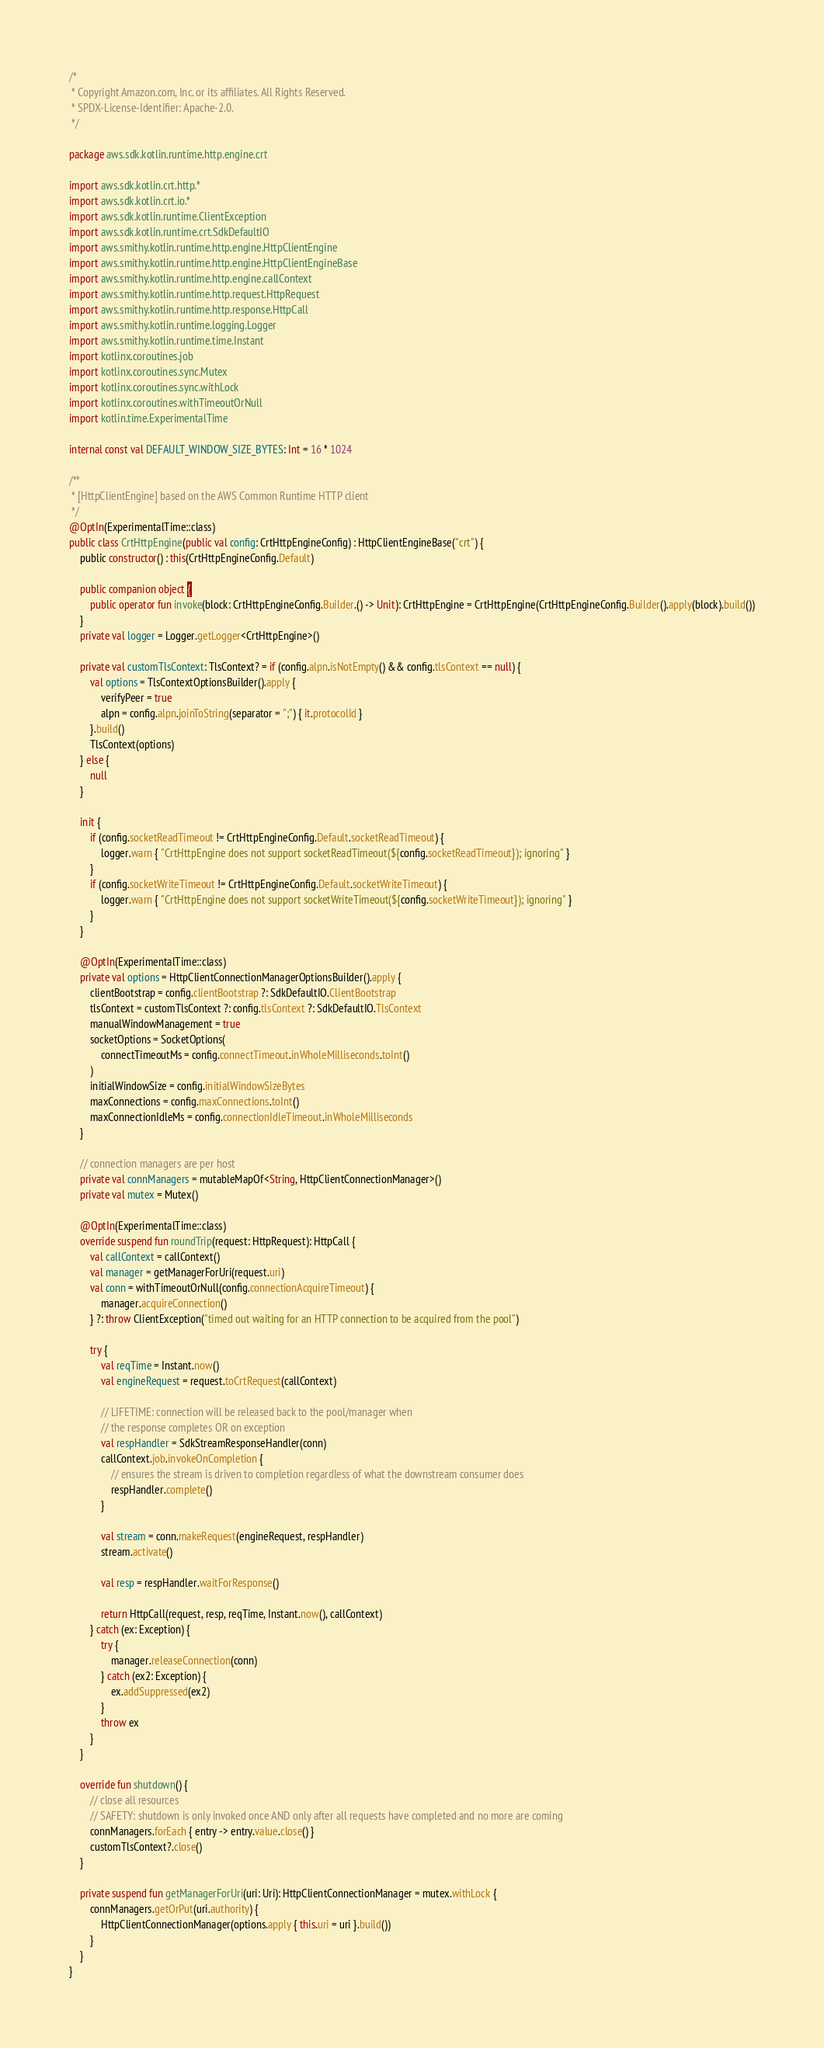Convert code to text. <code><loc_0><loc_0><loc_500><loc_500><_Kotlin_>/*
 * Copyright Amazon.com, Inc. or its affiliates. All Rights Reserved.
 * SPDX-License-Identifier: Apache-2.0.
 */

package aws.sdk.kotlin.runtime.http.engine.crt

import aws.sdk.kotlin.crt.http.*
import aws.sdk.kotlin.crt.io.*
import aws.sdk.kotlin.runtime.ClientException
import aws.sdk.kotlin.runtime.crt.SdkDefaultIO
import aws.smithy.kotlin.runtime.http.engine.HttpClientEngine
import aws.smithy.kotlin.runtime.http.engine.HttpClientEngineBase
import aws.smithy.kotlin.runtime.http.engine.callContext
import aws.smithy.kotlin.runtime.http.request.HttpRequest
import aws.smithy.kotlin.runtime.http.response.HttpCall
import aws.smithy.kotlin.runtime.logging.Logger
import aws.smithy.kotlin.runtime.time.Instant
import kotlinx.coroutines.job
import kotlinx.coroutines.sync.Mutex
import kotlinx.coroutines.sync.withLock
import kotlinx.coroutines.withTimeoutOrNull
import kotlin.time.ExperimentalTime

internal const val DEFAULT_WINDOW_SIZE_BYTES: Int = 16 * 1024

/**
 * [HttpClientEngine] based on the AWS Common Runtime HTTP client
 */
@OptIn(ExperimentalTime::class)
public class CrtHttpEngine(public val config: CrtHttpEngineConfig) : HttpClientEngineBase("crt") {
    public constructor() : this(CrtHttpEngineConfig.Default)

    public companion object {
        public operator fun invoke(block: CrtHttpEngineConfig.Builder.() -> Unit): CrtHttpEngine = CrtHttpEngine(CrtHttpEngineConfig.Builder().apply(block).build())
    }
    private val logger = Logger.getLogger<CrtHttpEngine>()

    private val customTlsContext: TlsContext? = if (config.alpn.isNotEmpty() && config.tlsContext == null) {
        val options = TlsContextOptionsBuilder().apply {
            verifyPeer = true
            alpn = config.alpn.joinToString(separator = ";") { it.protocolId }
        }.build()
        TlsContext(options)
    } else {
        null
    }

    init {
        if (config.socketReadTimeout != CrtHttpEngineConfig.Default.socketReadTimeout) {
            logger.warn { "CrtHttpEngine does not support socketReadTimeout(${config.socketReadTimeout}); ignoring" }
        }
        if (config.socketWriteTimeout != CrtHttpEngineConfig.Default.socketWriteTimeout) {
            logger.warn { "CrtHttpEngine does not support socketWriteTimeout(${config.socketWriteTimeout}); ignoring" }
        }
    }

    @OptIn(ExperimentalTime::class)
    private val options = HttpClientConnectionManagerOptionsBuilder().apply {
        clientBootstrap = config.clientBootstrap ?: SdkDefaultIO.ClientBootstrap
        tlsContext = customTlsContext ?: config.tlsContext ?: SdkDefaultIO.TlsContext
        manualWindowManagement = true
        socketOptions = SocketOptions(
            connectTimeoutMs = config.connectTimeout.inWholeMilliseconds.toInt()
        )
        initialWindowSize = config.initialWindowSizeBytes
        maxConnections = config.maxConnections.toInt()
        maxConnectionIdleMs = config.connectionIdleTimeout.inWholeMilliseconds
    }

    // connection managers are per host
    private val connManagers = mutableMapOf<String, HttpClientConnectionManager>()
    private val mutex = Mutex()

    @OptIn(ExperimentalTime::class)
    override suspend fun roundTrip(request: HttpRequest): HttpCall {
        val callContext = callContext()
        val manager = getManagerForUri(request.uri)
        val conn = withTimeoutOrNull(config.connectionAcquireTimeout) {
            manager.acquireConnection()
        } ?: throw ClientException("timed out waiting for an HTTP connection to be acquired from the pool")

        try {
            val reqTime = Instant.now()
            val engineRequest = request.toCrtRequest(callContext)

            // LIFETIME: connection will be released back to the pool/manager when
            // the response completes OR on exception
            val respHandler = SdkStreamResponseHandler(conn)
            callContext.job.invokeOnCompletion {
                // ensures the stream is driven to completion regardless of what the downstream consumer does
                respHandler.complete()
            }

            val stream = conn.makeRequest(engineRequest, respHandler)
            stream.activate()

            val resp = respHandler.waitForResponse()

            return HttpCall(request, resp, reqTime, Instant.now(), callContext)
        } catch (ex: Exception) {
            try {
                manager.releaseConnection(conn)
            } catch (ex2: Exception) {
                ex.addSuppressed(ex2)
            }
            throw ex
        }
    }

    override fun shutdown() {
        // close all resources
        // SAFETY: shutdown is only invoked once AND only after all requests have completed and no more are coming
        connManagers.forEach { entry -> entry.value.close() }
        customTlsContext?.close()
    }

    private suspend fun getManagerForUri(uri: Uri): HttpClientConnectionManager = mutex.withLock {
        connManagers.getOrPut(uri.authority) {
            HttpClientConnectionManager(options.apply { this.uri = uri }.build())
        }
    }
}
</code> 